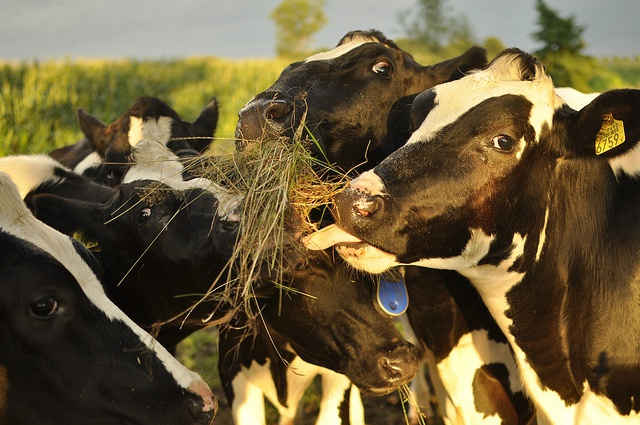Describe the objects in this image and their specific colors. I can see cow in darkgray, black, maroon, and olive tones, cow in darkgray, black, tan, and olive tones, cow in darkgray, black, and tan tones, cow in darkgray, black, maroon, and olive tones, and cow in darkgray, black, olive, and tan tones in this image. 